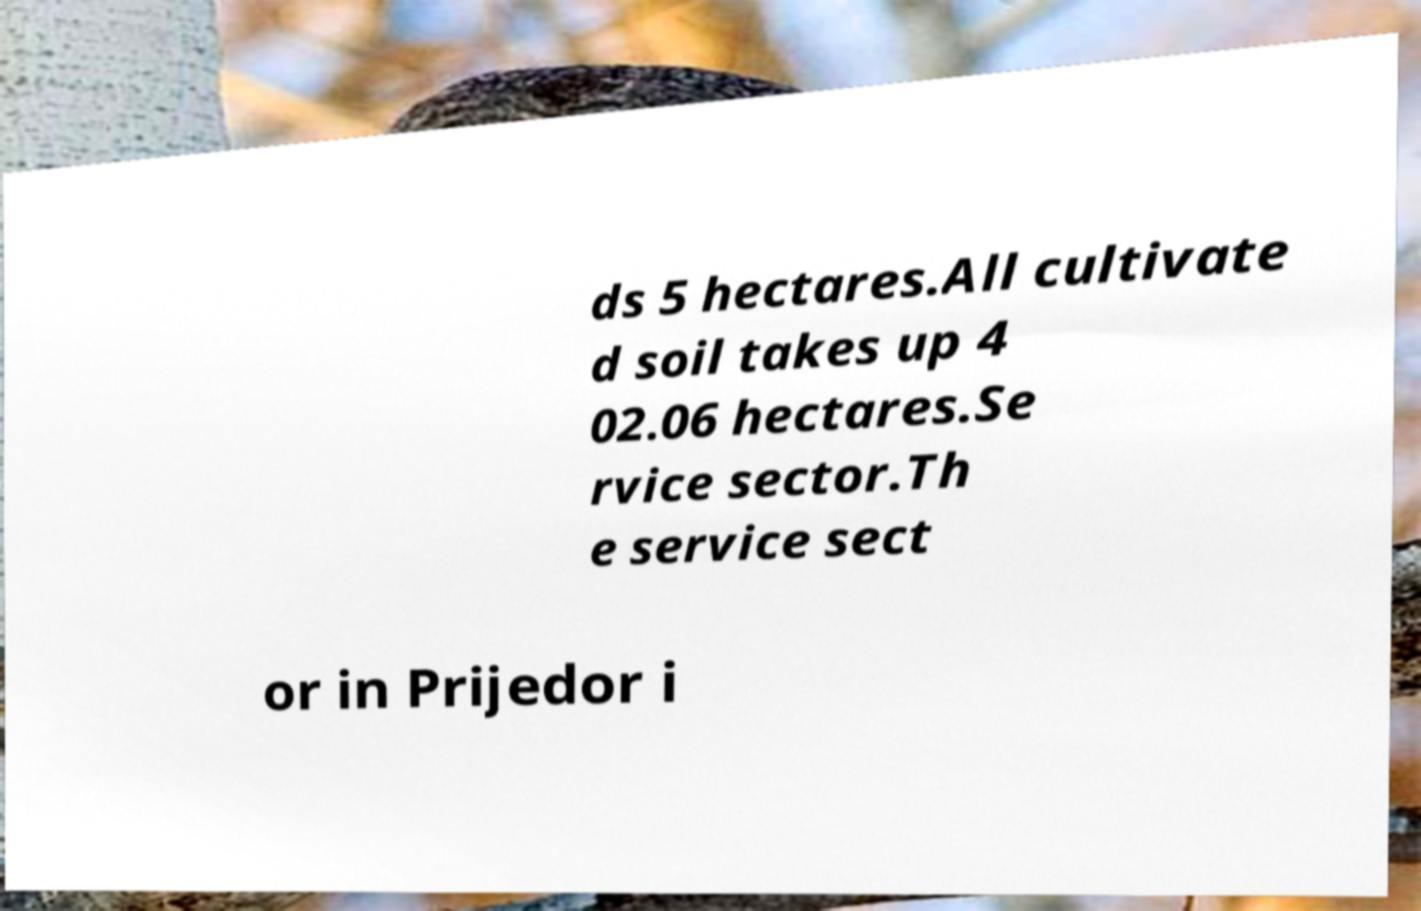There's text embedded in this image that I need extracted. Can you transcribe it verbatim? ds 5 hectares.All cultivate d soil takes up 4 02.06 hectares.Se rvice sector.Th e service sect or in Prijedor i 